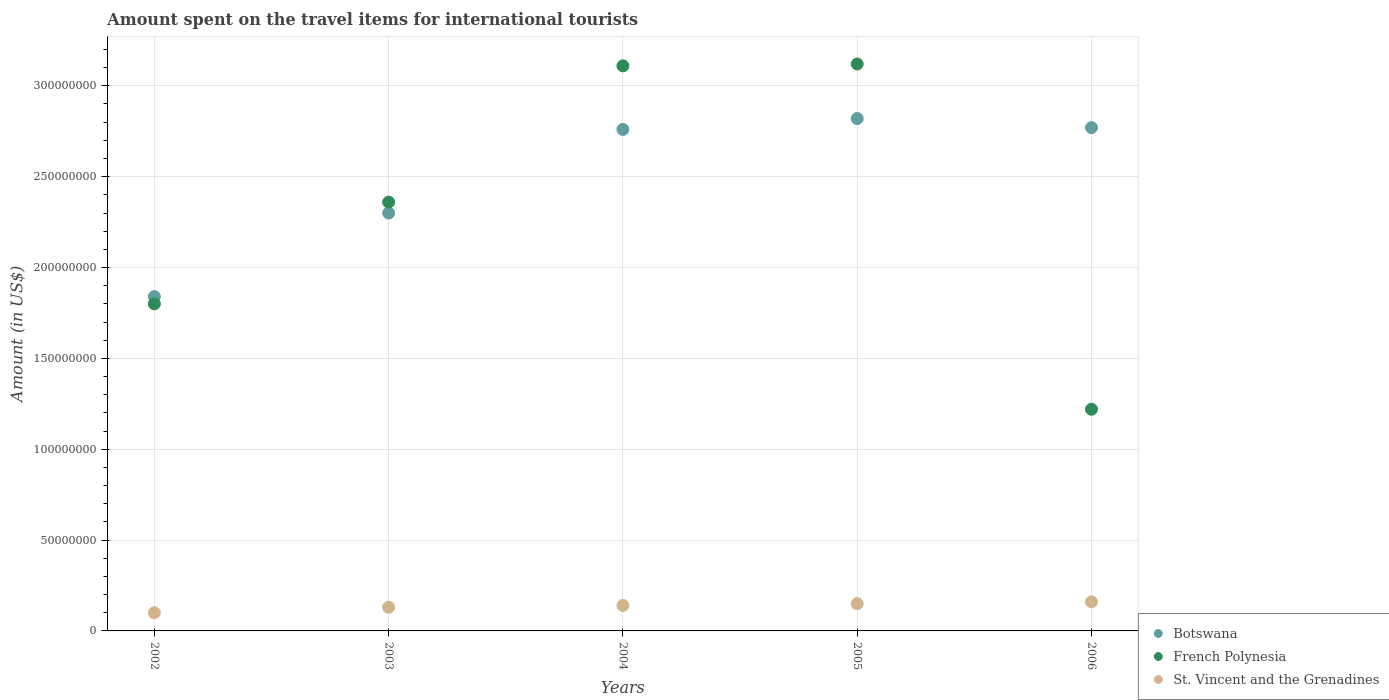What is the amount spent on the travel items for international tourists in St. Vincent and the Grenadines in 2004?
Ensure brevity in your answer.  1.40e+07. Across all years, what is the maximum amount spent on the travel items for international tourists in Botswana?
Your answer should be very brief. 2.82e+08. Across all years, what is the minimum amount spent on the travel items for international tourists in St. Vincent and the Grenadines?
Provide a succinct answer. 1.00e+07. In which year was the amount spent on the travel items for international tourists in St. Vincent and the Grenadines maximum?
Provide a succinct answer. 2006. What is the total amount spent on the travel items for international tourists in Botswana in the graph?
Offer a very short reply. 1.25e+09. What is the difference between the amount spent on the travel items for international tourists in Botswana in 2002 and that in 2005?
Provide a short and direct response. -9.80e+07. What is the difference between the amount spent on the travel items for international tourists in Botswana in 2002 and the amount spent on the travel items for international tourists in St. Vincent and the Grenadines in 2005?
Your response must be concise. 1.69e+08. What is the average amount spent on the travel items for international tourists in Botswana per year?
Your answer should be compact. 2.50e+08. In the year 2005, what is the difference between the amount spent on the travel items for international tourists in St. Vincent and the Grenadines and amount spent on the travel items for international tourists in French Polynesia?
Give a very brief answer. -2.97e+08. What is the ratio of the amount spent on the travel items for international tourists in St. Vincent and the Grenadines in 2002 to that in 2004?
Your answer should be very brief. 0.71. Is the amount spent on the travel items for international tourists in Botswana in 2002 less than that in 2003?
Make the answer very short. Yes. What is the difference between the highest and the second highest amount spent on the travel items for international tourists in St. Vincent and the Grenadines?
Provide a succinct answer. 1.00e+06. What is the difference between the highest and the lowest amount spent on the travel items for international tourists in French Polynesia?
Make the answer very short. 1.90e+08. Is the sum of the amount spent on the travel items for international tourists in French Polynesia in 2003 and 2006 greater than the maximum amount spent on the travel items for international tourists in Botswana across all years?
Provide a succinct answer. Yes. Does the amount spent on the travel items for international tourists in St. Vincent and the Grenadines monotonically increase over the years?
Provide a short and direct response. Yes. Is the amount spent on the travel items for international tourists in Botswana strictly less than the amount spent on the travel items for international tourists in St. Vincent and the Grenadines over the years?
Your answer should be compact. No. What is the difference between two consecutive major ticks on the Y-axis?
Give a very brief answer. 5.00e+07. Are the values on the major ticks of Y-axis written in scientific E-notation?
Keep it short and to the point. No. Does the graph contain any zero values?
Give a very brief answer. No. Does the graph contain grids?
Offer a very short reply. Yes. Where does the legend appear in the graph?
Provide a succinct answer. Bottom right. How many legend labels are there?
Your answer should be compact. 3. How are the legend labels stacked?
Your response must be concise. Vertical. What is the title of the graph?
Give a very brief answer. Amount spent on the travel items for international tourists. Does "Other small states" appear as one of the legend labels in the graph?
Keep it short and to the point. No. What is the Amount (in US$) of Botswana in 2002?
Ensure brevity in your answer.  1.84e+08. What is the Amount (in US$) of French Polynesia in 2002?
Ensure brevity in your answer.  1.80e+08. What is the Amount (in US$) in St. Vincent and the Grenadines in 2002?
Your response must be concise. 1.00e+07. What is the Amount (in US$) of Botswana in 2003?
Offer a very short reply. 2.30e+08. What is the Amount (in US$) in French Polynesia in 2003?
Give a very brief answer. 2.36e+08. What is the Amount (in US$) in St. Vincent and the Grenadines in 2003?
Provide a short and direct response. 1.30e+07. What is the Amount (in US$) of Botswana in 2004?
Your answer should be very brief. 2.76e+08. What is the Amount (in US$) of French Polynesia in 2004?
Ensure brevity in your answer.  3.11e+08. What is the Amount (in US$) in St. Vincent and the Grenadines in 2004?
Give a very brief answer. 1.40e+07. What is the Amount (in US$) in Botswana in 2005?
Ensure brevity in your answer.  2.82e+08. What is the Amount (in US$) in French Polynesia in 2005?
Offer a very short reply. 3.12e+08. What is the Amount (in US$) in St. Vincent and the Grenadines in 2005?
Offer a terse response. 1.50e+07. What is the Amount (in US$) in Botswana in 2006?
Provide a succinct answer. 2.77e+08. What is the Amount (in US$) in French Polynesia in 2006?
Ensure brevity in your answer.  1.22e+08. What is the Amount (in US$) in St. Vincent and the Grenadines in 2006?
Give a very brief answer. 1.60e+07. Across all years, what is the maximum Amount (in US$) in Botswana?
Your response must be concise. 2.82e+08. Across all years, what is the maximum Amount (in US$) of French Polynesia?
Your response must be concise. 3.12e+08. Across all years, what is the maximum Amount (in US$) in St. Vincent and the Grenadines?
Your answer should be very brief. 1.60e+07. Across all years, what is the minimum Amount (in US$) of Botswana?
Your answer should be very brief. 1.84e+08. Across all years, what is the minimum Amount (in US$) in French Polynesia?
Make the answer very short. 1.22e+08. Across all years, what is the minimum Amount (in US$) in St. Vincent and the Grenadines?
Keep it short and to the point. 1.00e+07. What is the total Amount (in US$) of Botswana in the graph?
Keep it short and to the point. 1.25e+09. What is the total Amount (in US$) in French Polynesia in the graph?
Provide a short and direct response. 1.16e+09. What is the total Amount (in US$) of St. Vincent and the Grenadines in the graph?
Offer a very short reply. 6.80e+07. What is the difference between the Amount (in US$) in Botswana in 2002 and that in 2003?
Your answer should be compact. -4.60e+07. What is the difference between the Amount (in US$) of French Polynesia in 2002 and that in 2003?
Give a very brief answer. -5.60e+07. What is the difference between the Amount (in US$) of St. Vincent and the Grenadines in 2002 and that in 2003?
Provide a succinct answer. -3.00e+06. What is the difference between the Amount (in US$) of Botswana in 2002 and that in 2004?
Ensure brevity in your answer.  -9.20e+07. What is the difference between the Amount (in US$) in French Polynesia in 2002 and that in 2004?
Your response must be concise. -1.31e+08. What is the difference between the Amount (in US$) of St. Vincent and the Grenadines in 2002 and that in 2004?
Your answer should be compact. -4.00e+06. What is the difference between the Amount (in US$) in Botswana in 2002 and that in 2005?
Your answer should be very brief. -9.80e+07. What is the difference between the Amount (in US$) of French Polynesia in 2002 and that in 2005?
Make the answer very short. -1.32e+08. What is the difference between the Amount (in US$) in St. Vincent and the Grenadines in 2002 and that in 2005?
Keep it short and to the point. -5.00e+06. What is the difference between the Amount (in US$) of Botswana in 2002 and that in 2006?
Provide a short and direct response. -9.30e+07. What is the difference between the Amount (in US$) in French Polynesia in 2002 and that in 2006?
Provide a short and direct response. 5.80e+07. What is the difference between the Amount (in US$) in St. Vincent and the Grenadines in 2002 and that in 2006?
Your answer should be very brief. -6.00e+06. What is the difference between the Amount (in US$) of Botswana in 2003 and that in 2004?
Your response must be concise. -4.60e+07. What is the difference between the Amount (in US$) of French Polynesia in 2003 and that in 2004?
Offer a terse response. -7.50e+07. What is the difference between the Amount (in US$) in St. Vincent and the Grenadines in 2003 and that in 2004?
Ensure brevity in your answer.  -1.00e+06. What is the difference between the Amount (in US$) of Botswana in 2003 and that in 2005?
Make the answer very short. -5.20e+07. What is the difference between the Amount (in US$) in French Polynesia in 2003 and that in 2005?
Your answer should be compact. -7.60e+07. What is the difference between the Amount (in US$) in Botswana in 2003 and that in 2006?
Your answer should be very brief. -4.70e+07. What is the difference between the Amount (in US$) of French Polynesia in 2003 and that in 2006?
Offer a terse response. 1.14e+08. What is the difference between the Amount (in US$) of St. Vincent and the Grenadines in 2003 and that in 2006?
Ensure brevity in your answer.  -3.00e+06. What is the difference between the Amount (in US$) of Botswana in 2004 and that in 2005?
Give a very brief answer. -6.00e+06. What is the difference between the Amount (in US$) in French Polynesia in 2004 and that in 2006?
Give a very brief answer. 1.89e+08. What is the difference between the Amount (in US$) of St. Vincent and the Grenadines in 2004 and that in 2006?
Give a very brief answer. -2.00e+06. What is the difference between the Amount (in US$) of Botswana in 2005 and that in 2006?
Make the answer very short. 5.00e+06. What is the difference between the Amount (in US$) of French Polynesia in 2005 and that in 2006?
Give a very brief answer. 1.90e+08. What is the difference between the Amount (in US$) of St. Vincent and the Grenadines in 2005 and that in 2006?
Offer a very short reply. -1.00e+06. What is the difference between the Amount (in US$) of Botswana in 2002 and the Amount (in US$) of French Polynesia in 2003?
Offer a terse response. -5.20e+07. What is the difference between the Amount (in US$) in Botswana in 2002 and the Amount (in US$) in St. Vincent and the Grenadines in 2003?
Provide a succinct answer. 1.71e+08. What is the difference between the Amount (in US$) in French Polynesia in 2002 and the Amount (in US$) in St. Vincent and the Grenadines in 2003?
Give a very brief answer. 1.67e+08. What is the difference between the Amount (in US$) of Botswana in 2002 and the Amount (in US$) of French Polynesia in 2004?
Offer a very short reply. -1.27e+08. What is the difference between the Amount (in US$) of Botswana in 2002 and the Amount (in US$) of St. Vincent and the Grenadines in 2004?
Keep it short and to the point. 1.70e+08. What is the difference between the Amount (in US$) in French Polynesia in 2002 and the Amount (in US$) in St. Vincent and the Grenadines in 2004?
Provide a succinct answer. 1.66e+08. What is the difference between the Amount (in US$) in Botswana in 2002 and the Amount (in US$) in French Polynesia in 2005?
Offer a terse response. -1.28e+08. What is the difference between the Amount (in US$) of Botswana in 2002 and the Amount (in US$) of St. Vincent and the Grenadines in 2005?
Ensure brevity in your answer.  1.69e+08. What is the difference between the Amount (in US$) in French Polynesia in 2002 and the Amount (in US$) in St. Vincent and the Grenadines in 2005?
Ensure brevity in your answer.  1.65e+08. What is the difference between the Amount (in US$) of Botswana in 2002 and the Amount (in US$) of French Polynesia in 2006?
Make the answer very short. 6.20e+07. What is the difference between the Amount (in US$) in Botswana in 2002 and the Amount (in US$) in St. Vincent and the Grenadines in 2006?
Give a very brief answer. 1.68e+08. What is the difference between the Amount (in US$) in French Polynesia in 2002 and the Amount (in US$) in St. Vincent and the Grenadines in 2006?
Provide a succinct answer. 1.64e+08. What is the difference between the Amount (in US$) in Botswana in 2003 and the Amount (in US$) in French Polynesia in 2004?
Offer a very short reply. -8.10e+07. What is the difference between the Amount (in US$) of Botswana in 2003 and the Amount (in US$) of St. Vincent and the Grenadines in 2004?
Offer a terse response. 2.16e+08. What is the difference between the Amount (in US$) of French Polynesia in 2003 and the Amount (in US$) of St. Vincent and the Grenadines in 2004?
Keep it short and to the point. 2.22e+08. What is the difference between the Amount (in US$) of Botswana in 2003 and the Amount (in US$) of French Polynesia in 2005?
Offer a terse response. -8.20e+07. What is the difference between the Amount (in US$) of Botswana in 2003 and the Amount (in US$) of St. Vincent and the Grenadines in 2005?
Keep it short and to the point. 2.15e+08. What is the difference between the Amount (in US$) of French Polynesia in 2003 and the Amount (in US$) of St. Vincent and the Grenadines in 2005?
Offer a terse response. 2.21e+08. What is the difference between the Amount (in US$) of Botswana in 2003 and the Amount (in US$) of French Polynesia in 2006?
Your response must be concise. 1.08e+08. What is the difference between the Amount (in US$) in Botswana in 2003 and the Amount (in US$) in St. Vincent and the Grenadines in 2006?
Keep it short and to the point. 2.14e+08. What is the difference between the Amount (in US$) of French Polynesia in 2003 and the Amount (in US$) of St. Vincent and the Grenadines in 2006?
Offer a very short reply. 2.20e+08. What is the difference between the Amount (in US$) of Botswana in 2004 and the Amount (in US$) of French Polynesia in 2005?
Make the answer very short. -3.60e+07. What is the difference between the Amount (in US$) of Botswana in 2004 and the Amount (in US$) of St. Vincent and the Grenadines in 2005?
Your response must be concise. 2.61e+08. What is the difference between the Amount (in US$) of French Polynesia in 2004 and the Amount (in US$) of St. Vincent and the Grenadines in 2005?
Ensure brevity in your answer.  2.96e+08. What is the difference between the Amount (in US$) of Botswana in 2004 and the Amount (in US$) of French Polynesia in 2006?
Give a very brief answer. 1.54e+08. What is the difference between the Amount (in US$) in Botswana in 2004 and the Amount (in US$) in St. Vincent and the Grenadines in 2006?
Make the answer very short. 2.60e+08. What is the difference between the Amount (in US$) in French Polynesia in 2004 and the Amount (in US$) in St. Vincent and the Grenadines in 2006?
Ensure brevity in your answer.  2.95e+08. What is the difference between the Amount (in US$) in Botswana in 2005 and the Amount (in US$) in French Polynesia in 2006?
Your answer should be very brief. 1.60e+08. What is the difference between the Amount (in US$) in Botswana in 2005 and the Amount (in US$) in St. Vincent and the Grenadines in 2006?
Keep it short and to the point. 2.66e+08. What is the difference between the Amount (in US$) of French Polynesia in 2005 and the Amount (in US$) of St. Vincent and the Grenadines in 2006?
Offer a very short reply. 2.96e+08. What is the average Amount (in US$) in Botswana per year?
Ensure brevity in your answer.  2.50e+08. What is the average Amount (in US$) in French Polynesia per year?
Provide a succinct answer. 2.32e+08. What is the average Amount (in US$) in St. Vincent and the Grenadines per year?
Your response must be concise. 1.36e+07. In the year 2002, what is the difference between the Amount (in US$) of Botswana and Amount (in US$) of French Polynesia?
Your answer should be compact. 4.00e+06. In the year 2002, what is the difference between the Amount (in US$) in Botswana and Amount (in US$) in St. Vincent and the Grenadines?
Your response must be concise. 1.74e+08. In the year 2002, what is the difference between the Amount (in US$) of French Polynesia and Amount (in US$) of St. Vincent and the Grenadines?
Offer a very short reply. 1.70e+08. In the year 2003, what is the difference between the Amount (in US$) of Botswana and Amount (in US$) of French Polynesia?
Your response must be concise. -6.00e+06. In the year 2003, what is the difference between the Amount (in US$) of Botswana and Amount (in US$) of St. Vincent and the Grenadines?
Provide a short and direct response. 2.17e+08. In the year 2003, what is the difference between the Amount (in US$) of French Polynesia and Amount (in US$) of St. Vincent and the Grenadines?
Your answer should be very brief. 2.23e+08. In the year 2004, what is the difference between the Amount (in US$) in Botswana and Amount (in US$) in French Polynesia?
Your response must be concise. -3.50e+07. In the year 2004, what is the difference between the Amount (in US$) in Botswana and Amount (in US$) in St. Vincent and the Grenadines?
Your answer should be very brief. 2.62e+08. In the year 2004, what is the difference between the Amount (in US$) of French Polynesia and Amount (in US$) of St. Vincent and the Grenadines?
Your answer should be compact. 2.97e+08. In the year 2005, what is the difference between the Amount (in US$) of Botswana and Amount (in US$) of French Polynesia?
Provide a succinct answer. -3.00e+07. In the year 2005, what is the difference between the Amount (in US$) in Botswana and Amount (in US$) in St. Vincent and the Grenadines?
Your answer should be very brief. 2.67e+08. In the year 2005, what is the difference between the Amount (in US$) in French Polynesia and Amount (in US$) in St. Vincent and the Grenadines?
Provide a short and direct response. 2.97e+08. In the year 2006, what is the difference between the Amount (in US$) in Botswana and Amount (in US$) in French Polynesia?
Give a very brief answer. 1.55e+08. In the year 2006, what is the difference between the Amount (in US$) of Botswana and Amount (in US$) of St. Vincent and the Grenadines?
Your answer should be compact. 2.61e+08. In the year 2006, what is the difference between the Amount (in US$) of French Polynesia and Amount (in US$) of St. Vincent and the Grenadines?
Offer a very short reply. 1.06e+08. What is the ratio of the Amount (in US$) of Botswana in 2002 to that in 2003?
Give a very brief answer. 0.8. What is the ratio of the Amount (in US$) in French Polynesia in 2002 to that in 2003?
Offer a terse response. 0.76. What is the ratio of the Amount (in US$) of St. Vincent and the Grenadines in 2002 to that in 2003?
Ensure brevity in your answer.  0.77. What is the ratio of the Amount (in US$) in Botswana in 2002 to that in 2004?
Offer a very short reply. 0.67. What is the ratio of the Amount (in US$) in French Polynesia in 2002 to that in 2004?
Keep it short and to the point. 0.58. What is the ratio of the Amount (in US$) in Botswana in 2002 to that in 2005?
Offer a terse response. 0.65. What is the ratio of the Amount (in US$) of French Polynesia in 2002 to that in 2005?
Your response must be concise. 0.58. What is the ratio of the Amount (in US$) in Botswana in 2002 to that in 2006?
Offer a terse response. 0.66. What is the ratio of the Amount (in US$) in French Polynesia in 2002 to that in 2006?
Ensure brevity in your answer.  1.48. What is the ratio of the Amount (in US$) of Botswana in 2003 to that in 2004?
Make the answer very short. 0.83. What is the ratio of the Amount (in US$) in French Polynesia in 2003 to that in 2004?
Your answer should be compact. 0.76. What is the ratio of the Amount (in US$) of Botswana in 2003 to that in 2005?
Offer a very short reply. 0.82. What is the ratio of the Amount (in US$) of French Polynesia in 2003 to that in 2005?
Offer a terse response. 0.76. What is the ratio of the Amount (in US$) of St. Vincent and the Grenadines in 2003 to that in 2005?
Your answer should be compact. 0.87. What is the ratio of the Amount (in US$) in Botswana in 2003 to that in 2006?
Offer a very short reply. 0.83. What is the ratio of the Amount (in US$) in French Polynesia in 2003 to that in 2006?
Your response must be concise. 1.93. What is the ratio of the Amount (in US$) of St. Vincent and the Grenadines in 2003 to that in 2006?
Your response must be concise. 0.81. What is the ratio of the Amount (in US$) in Botswana in 2004 to that in 2005?
Ensure brevity in your answer.  0.98. What is the ratio of the Amount (in US$) in French Polynesia in 2004 to that in 2005?
Offer a terse response. 1. What is the ratio of the Amount (in US$) of Botswana in 2004 to that in 2006?
Provide a short and direct response. 1. What is the ratio of the Amount (in US$) of French Polynesia in 2004 to that in 2006?
Offer a terse response. 2.55. What is the ratio of the Amount (in US$) of St. Vincent and the Grenadines in 2004 to that in 2006?
Keep it short and to the point. 0.88. What is the ratio of the Amount (in US$) of Botswana in 2005 to that in 2006?
Your answer should be very brief. 1.02. What is the ratio of the Amount (in US$) in French Polynesia in 2005 to that in 2006?
Offer a terse response. 2.56. What is the ratio of the Amount (in US$) in St. Vincent and the Grenadines in 2005 to that in 2006?
Give a very brief answer. 0.94. What is the difference between the highest and the second highest Amount (in US$) in Botswana?
Ensure brevity in your answer.  5.00e+06. What is the difference between the highest and the lowest Amount (in US$) of Botswana?
Your answer should be very brief. 9.80e+07. What is the difference between the highest and the lowest Amount (in US$) in French Polynesia?
Make the answer very short. 1.90e+08. What is the difference between the highest and the lowest Amount (in US$) of St. Vincent and the Grenadines?
Give a very brief answer. 6.00e+06. 